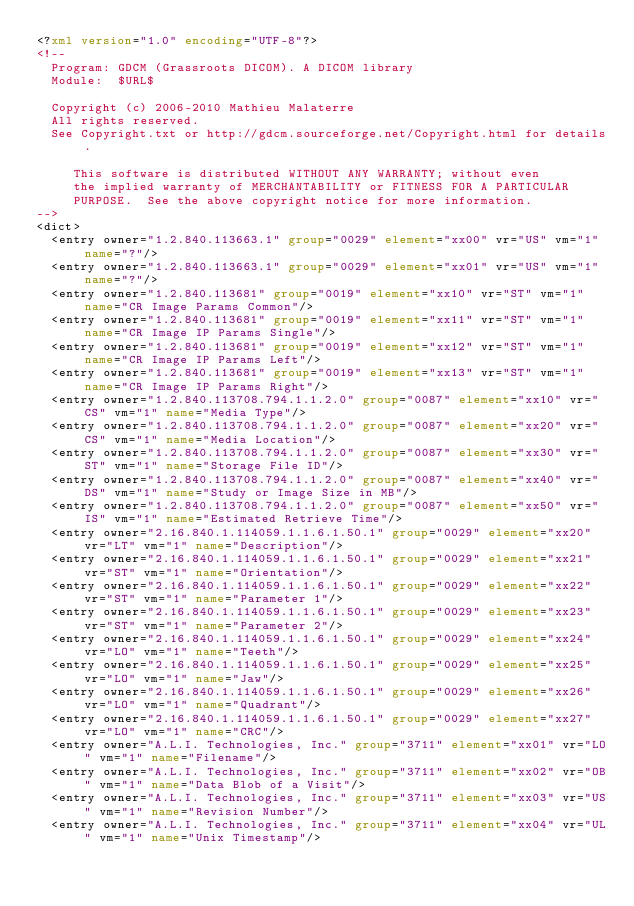Convert code to text. <code><loc_0><loc_0><loc_500><loc_500><_XML_><?xml version="1.0" encoding="UTF-8"?>
<!--
  Program: GDCM (Grassroots DICOM). A DICOM library
  Module:  $URL$

  Copyright (c) 2006-2010 Mathieu Malaterre
  All rights reserved.
  See Copyright.txt or http://gdcm.sourceforge.net/Copyright.html for details.

     This software is distributed WITHOUT ANY WARRANTY; without even
     the implied warranty of MERCHANTABILITY or FITNESS FOR A PARTICULAR
     PURPOSE.  See the above copyright notice for more information.
-->
<dict>
  <entry owner="1.2.840.113663.1" group="0029" element="xx00" vr="US" vm="1" name="?"/>
  <entry owner="1.2.840.113663.1" group="0029" element="xx01" vr="US" vm="1" name="?"/>
  <entry owner="1.2.840.113681" group="0019" element="xx10" vr="ST" vm="1" name="CR Image Params Common"/>
  <entry owner="1.2.840.113681" group="0019" element="xx11" vr="ST" vm="1" name="CR Image IP Params Single"/>
  <entry owner="1.2.840.113681" group="0019" element="xx12" vr="ST" vm="1" name="CR Image IP Params Left"/>
  <entry owner="1.2.840.113681" group="0019" element="xx13" vr="ST" vm="1" name="CR Image IP Params Right"/>
  <entry owner="1.2.840.113708.794.1.1.2.0" group="0087" element="xx10" vr="CS" vm="1" name="Media Type"/>
  <entry owner="1.2.840.113708.794.1.1.2.0" group="0087" element="xx20" vr="CS" vm="1" name="Media Location"/>
  <entry owner="1.2.840.113708.794.1.1.2.0" group="0087" element="xx30" vr="ST" vm="1" name="Storage File ID"/>
  <entry owner="1.2.840.113708.794.1.1.2.0" group="0087" element="xx40" vr="DS" vm="1" name="Study or Image Size in MB"/>
  <entry owner="1.2.840.113708.794.1.1.2.0" group="0087" element="xx50" vr="IS" vm="1" name="Estimated Retrieve Time"/>
  <entry owner="2.16.840.1.114059.1.1.6.1.50.1" group="0029" element="xx20" vr="LT" vm="1" name="Description"/>
  <entry owner="2.16.840.1.114059.1.1.6.1.50.1" group="0029" element="xx21" vr="ST" vm="1" name="Orientation"/>
  <entry owner="2.16.840.1.114059.1.1.6.1.50.1" group="0029" element="xx22" vr="ST" vm="1" name="Parameter 1"/>
  <entry owner="2.16.840.1.114059.1.1.6.1.50.1" group="0029" element="xx23" vr="ST" vm="1" name="Parameter 2"/>
  <entry owner="2.16.840.1.114059.1.1.6.1.50.1" group="0029" element="xx24" vr="LO" vm="1" name="Teeth"/>
  <entry owner="2.16.840.1.114059.1.1.6.1.50.1" group="0029" element="xx25" vr="LO" vm="1" name="Jaw"/>
  <entry owner="2.16.840.1.114059.1.1.6.1.50.1" group="0029" element="xx26" vr="LO" vm="1" name="Quadrant"/>
  <entry owner="2.16.840.1.114059.1.1.6.1.50.1" group="0029" element="xx27" vr="LO" vm="1" name="CRC"/>
  <entry owner="A.L.I. Technologies, Inc." group="3711" element="xx01" vr="LO" vm="1" name="Filename"/>
  <entry owner="A.L.I. Technologies, Inc." group="3711" element="xx02" vr="OB" vm="1" name="Data Blob of a Visit"/>
  <entry owner="A.L.I. Technologies, Inc." group="3711" element="xx03" vr="US" vm="1" name="Revision Number"/>
  <entry owner="A.L.I. Technologies, Inc." group="3711" element="xx04" vr="UL" vm="1" name="Unix Timestamp"/></code> 